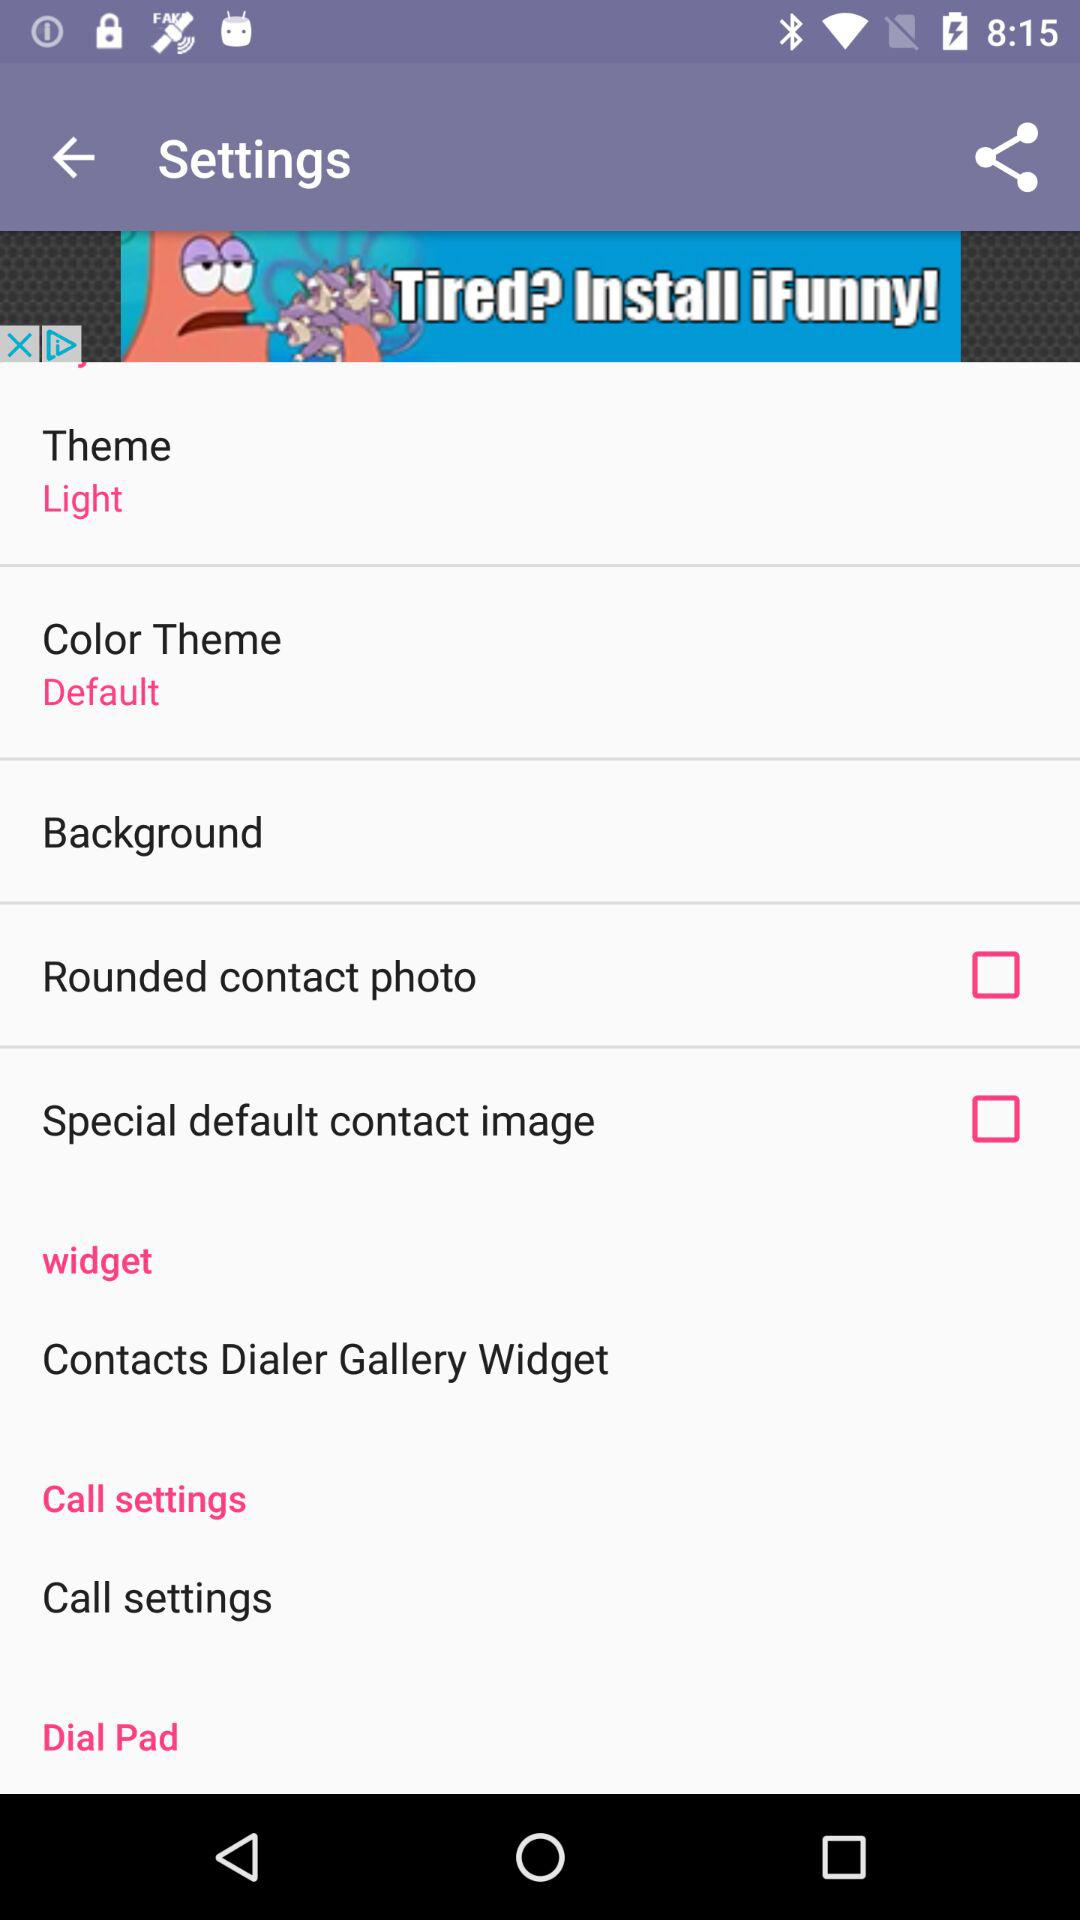How many items have a check box?
Answer the question using a single word or phrase. 2 